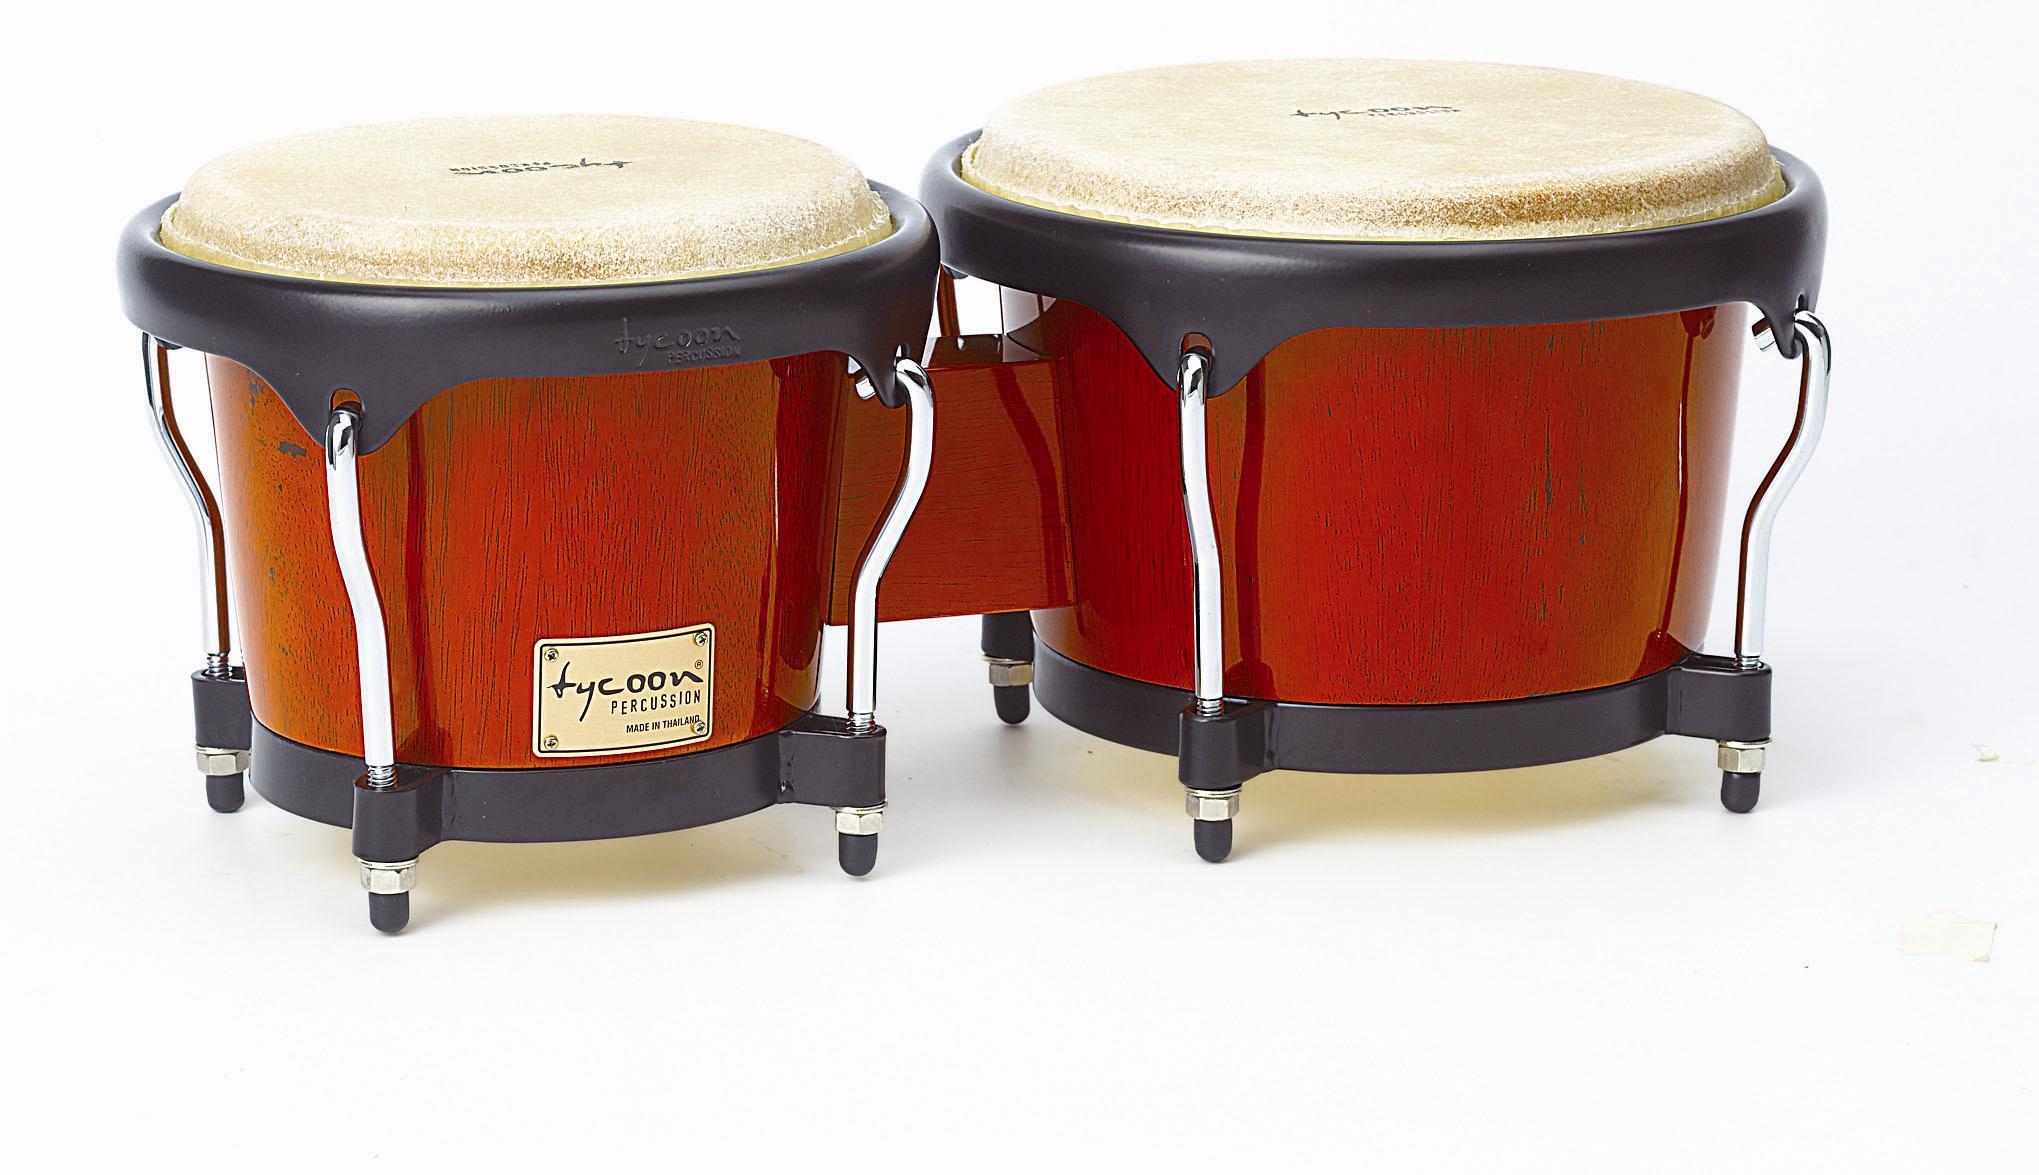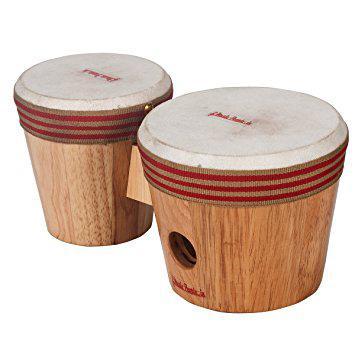The first image is the image on the left, the second image is the image on the right. Examine the images to the left and right. Is the description "There are exactly two pairs of bongo drums." accurate? Answer yes or no. Yes. The first image is the image on the left, the second image is the image on the right. Given the left and right images, does the statement "Each image shows a connected pair of drums, and one image features wood grain drums without a footed stand." hold true? Answer yes or no. Yes. 